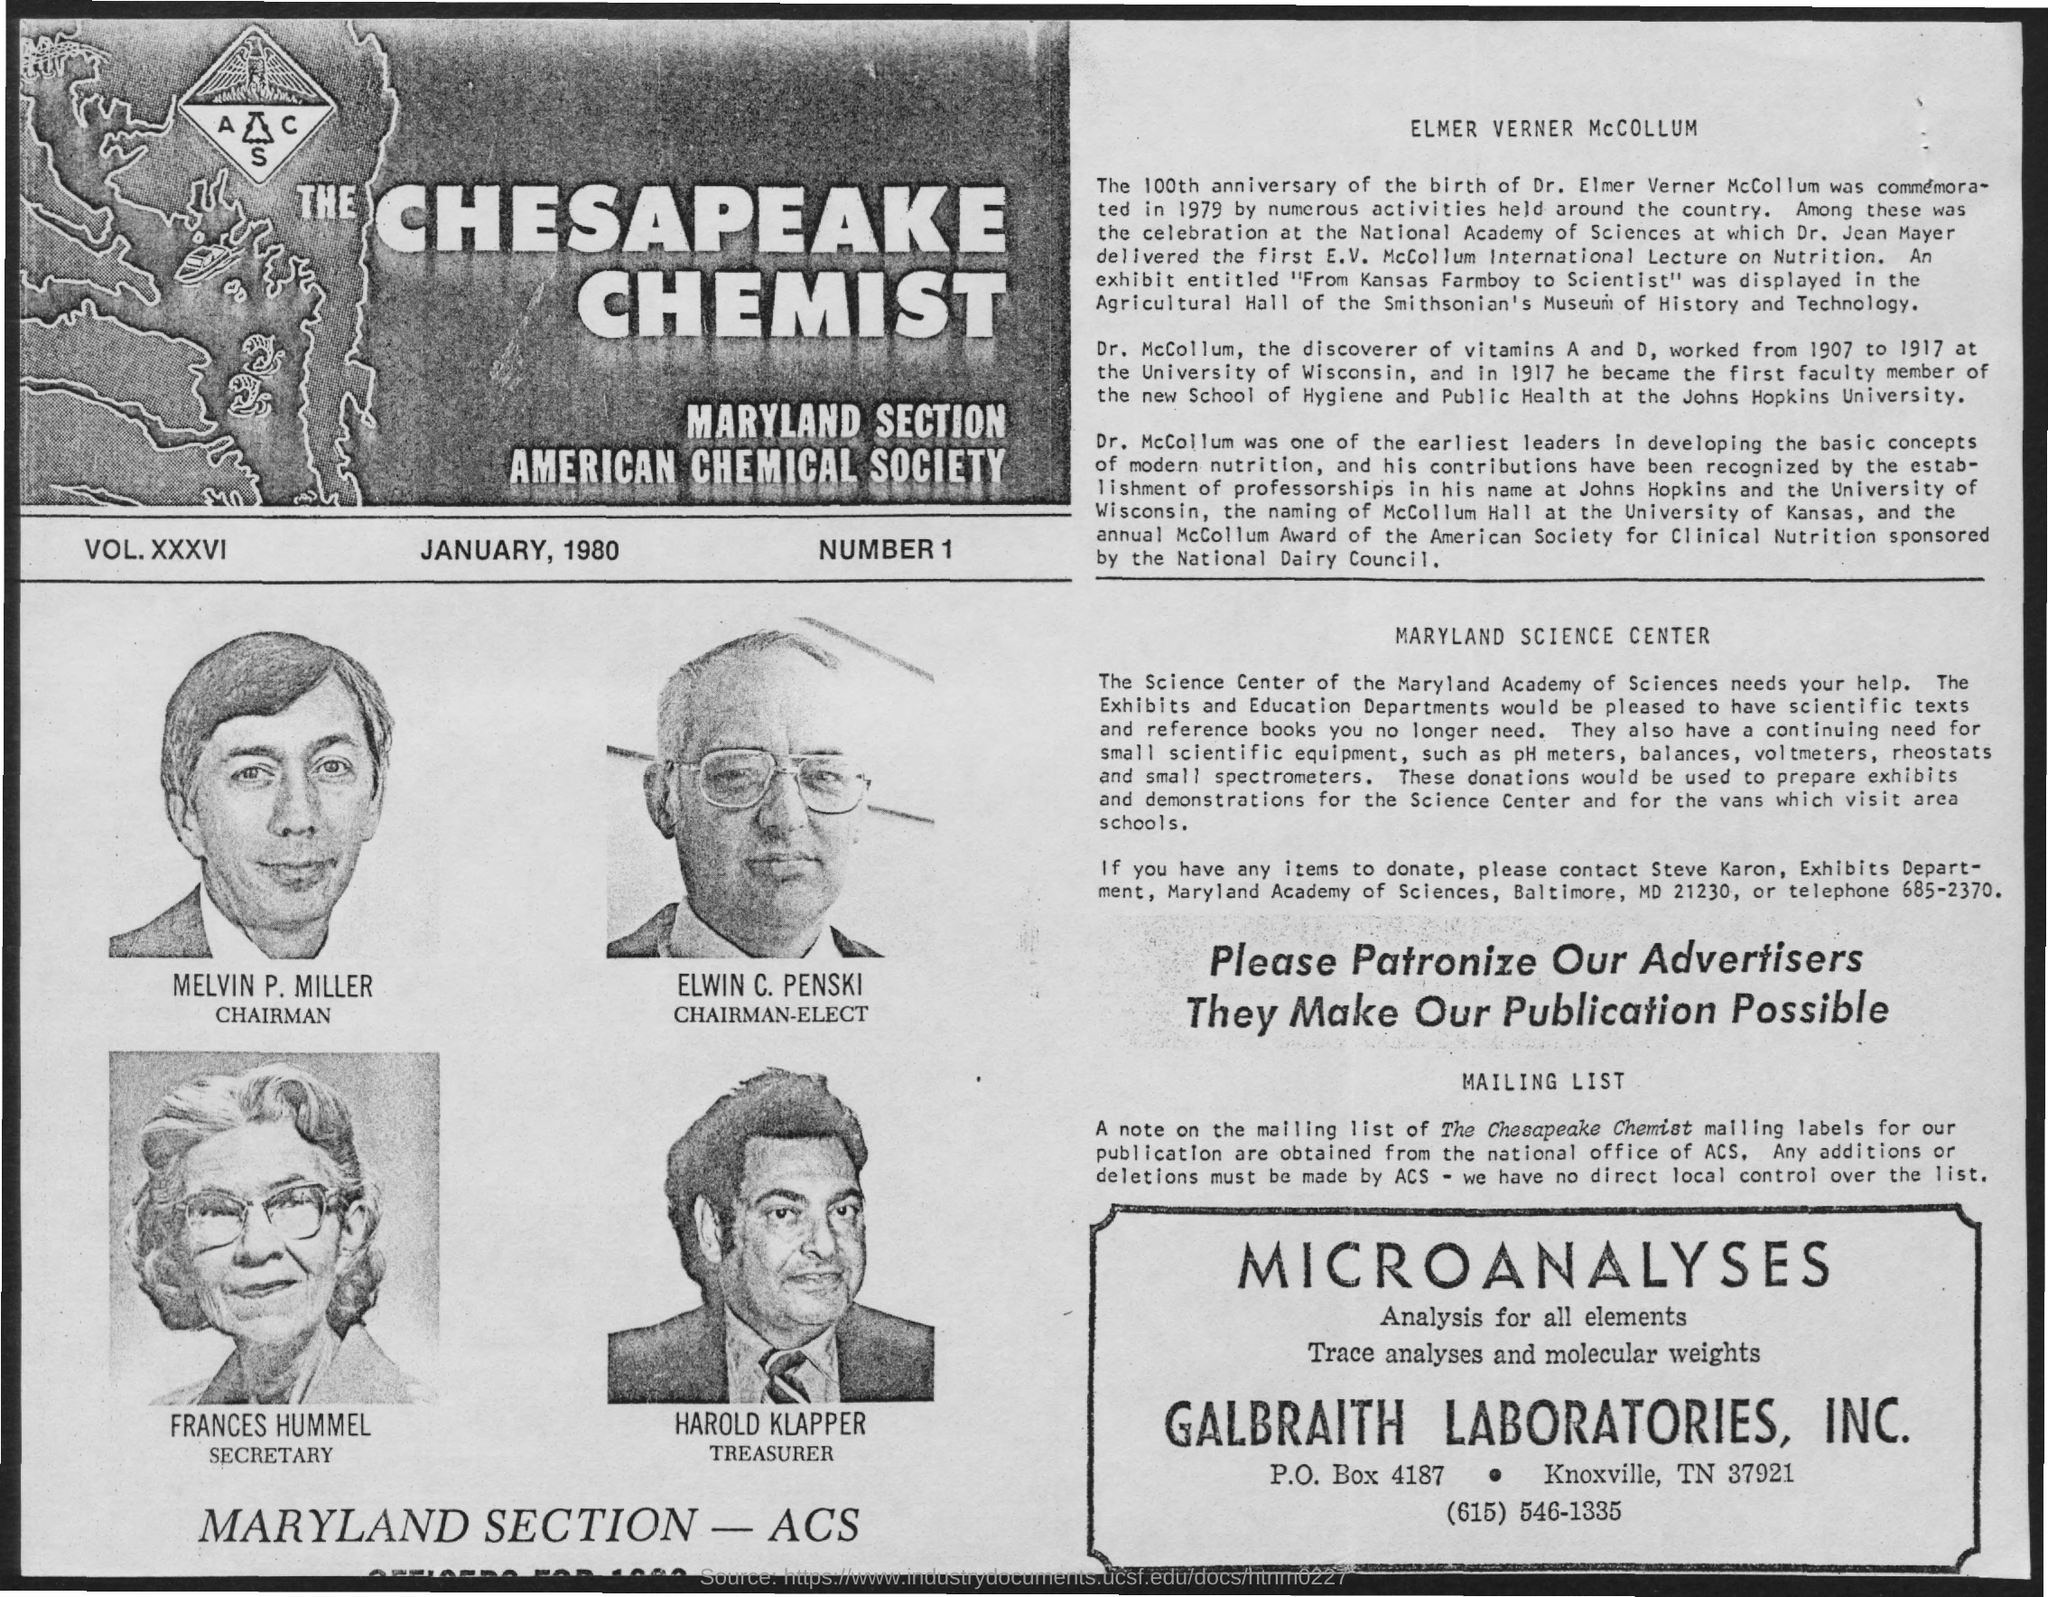Point out several critical features in this image. The treasurer's name is Harold Klapper. The Maryland section is the name of a particular section. The secretary's name is Frances Hummel. The American Chemical Society is the name of the society that was mentioned. The chairman-elect's name is Elwin C. Penski. 